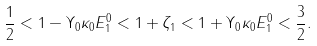Convert formula to latex. <formula><loc_0><loc_0><loc_500><loc_500>\frac { 1 } { 2 } < 1 - \Upsilon _ { 0 } \kappa _ { 0 } E _ { 1 } ^ { 0 } < 1 + \zeta _ { 1 } < 1 + \Upsilon _ { 0 } \kappa _ { 0 } E _ { 1 } ^ { 0 } < \frac { 3 } { 2 } .</formula> 